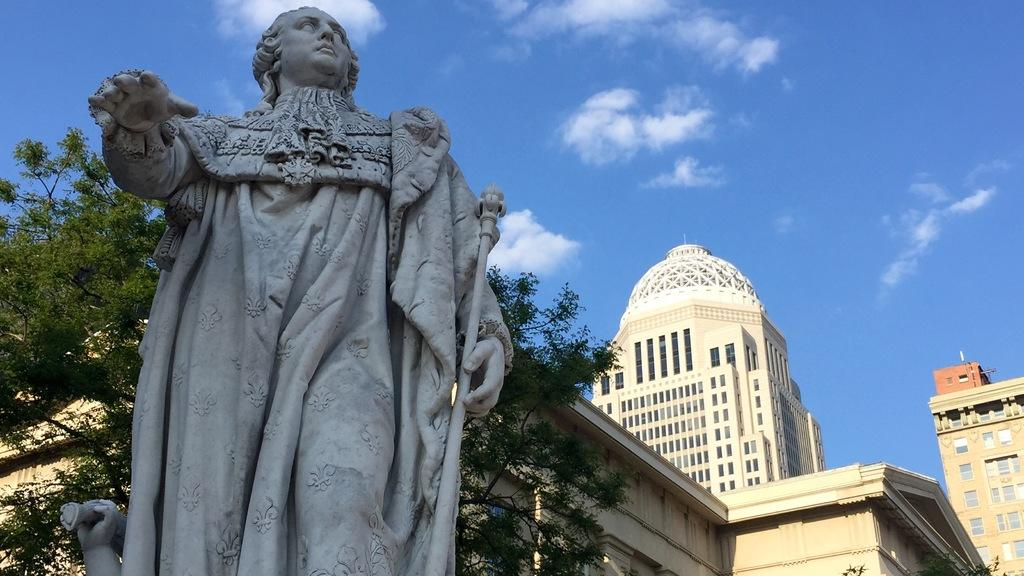What is the main subject in the image? There is a statue in the image. What can be seen behind the statue? There are trees and buildings behind the statue. What is visible at the top of the image? The sky is visible at the top of the image. What letters are written on the statue in the image? There are no letters written on the statue in the image. What type of plants can be seen growing around the statue? There is no mention of plants in the image, only trees and buildings are mentioned. 